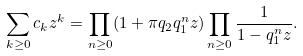<formula> <loc_0><loc_0><loc_500><loc_500>\sum _ { k \geq 0 } c _ { k } z ^ { k } = \prod _ { n \geq 0 } ( 1 + \pi q _ { 2 } q _ { 1 } ^ { n } z ) \prod _ { n \geq 0 } \frac { 1 } { 1 - q _ { 1 } ^ { n } z } .</formula> 